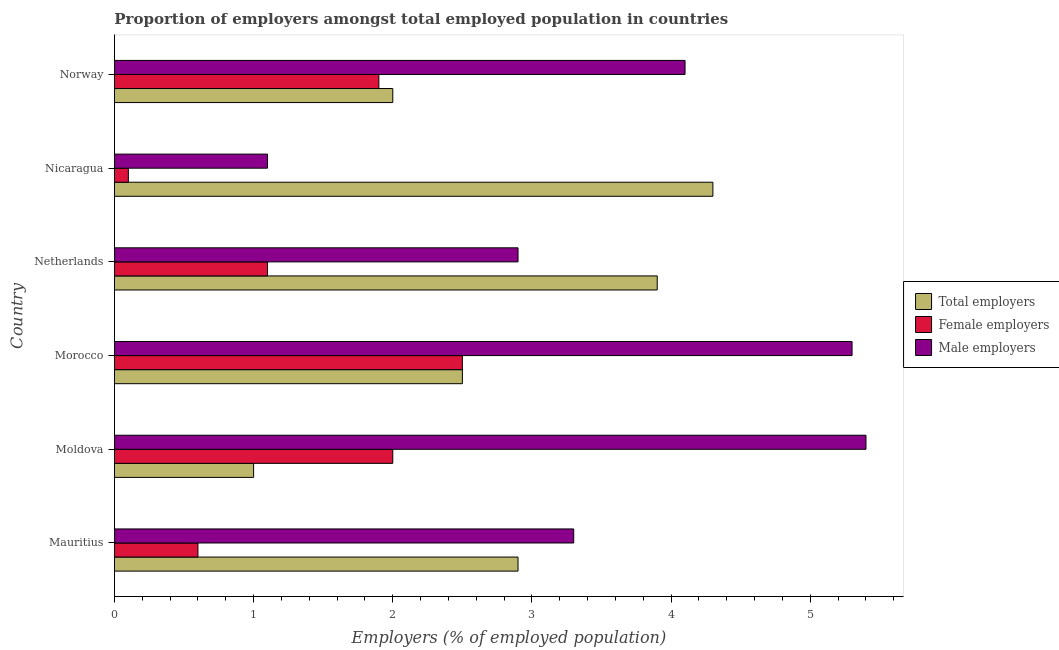How many different coloured bars are there?
Your answer should be compact. 3. Are the number of bars on each tick of the Y-axis equal?
Provide a short and direct response. Yes. How many bars are there on the 4th tick from the bottom?
Make the answer very short. 3. In how many cases, is the number of bars for a given country not equal to the number of legend labels?
Your answer should be very brief. 0. What is the percentage of male employers in Mauritius?
Your answer should be very brief. 3.3. In which country was the percentage of total employers maximum?
Make the answer very short. Nicaragua. In which country was the percentage of male employers minimum?
Offer a terse response. Nicaragua. What is the total percentage of male employers in the graph?
Provide a succinct answer. 22.1. What is the difference between the percentage of female employers in Moldova and that in Netherlands?
Offer a terse response. 0.9. What is the difference between the percentage of total employers in Norway and the percentage of female employers in Mauritius?
Keep it short and to the point. 1.4. What is the average percentage of female employers per country?
Offer a terse response. 1.37. In how many countries, is the percentage of female employers greater than 4 %?
Your answer should be compact. 0. What is the difference between the highest and the lowest percentage of male employers?
Provide a short and direct response. 4.3. What does the 2nd bar from the top in Norway represents?
Make the answer very short. Female employers. What does the 1st bar from the bottom in Mauritius represents?
Offer a terse response. Total employers. Is it the case that in every country, the sum of the percentage of total employers and percentage of female employers is greater than the percentage of male employers?
Provide a succinct answer. No. Are the values on the major ticks of X-axis written in scientific E-notation?
Offer a terse response. No. Does the graph contain any zero values?
Your answer should be compact. No. Does the graph contain grids?
Your response must be concise. No. Where does the legend appear in the graph?
Your response must be concise. Center right. What is the title of the graph?
Your answer should be compact. Proportion of employers amongst total employed population in countries. Does "Taxes on income" appear as one of the legend labels in the graph?
Give a very brief answer. No. What is the label or title of the X-axis?
Give a very brief answer. Employers (% of employed population). What is the label or title of the Y-axis?
Offer a terse response. Country. What is the Employers (% of employed population) of Total employers in Mauritius?
Your answer should be very brief. 2.9. What is the Employers (% of employed population) in Female employers in Mauritius?
Keep it short and to the point. 0.6. What is the Employers (% of employed population) in Male employers in Mauritius?
Your answer should be very brief. 3.3. What is the Employers (% of employed population) of Total employers in Moldova?
Keep it short and to the point. 1. What is the Employers (% of employed population) of Female employers in Moldova?
Give a very brief answer. 2. What is the Employers (% of employed population) of Male employers in Moldova?
Your response must be concise. 5.4. What is the Employers (% of employed population) of Male employers in Morocco?
Give a very brief answer. 5.3. What is the Employers (% of employed population) of Total employers in Netherlands?
Provide a succinct answer. 3.9. What is the Employers (% of employed population) in Female employers in Netherlands?
Keep it short and to the point. 1.1. What is the Employers (% of employed population) of Male employers in Netherlands?
Offer a terse response. 2.9. What is the Employers (% of employed population) in Total employers in Nicaragua?
Give a very brief answer. 4.3. What is the Employers (% of employed population) of Female employers in Nicaragua?
Ensure brevity in your answer.  0.1. What is the Employers (% of employed population) of Male employers in Nicaragua?
Give a very brief answer. 1.1. What is the Employers (% of employed population) of Total employers in Norway?
Your answer should be compact. 2. What is the Employers (% of employed population) of Female employers in Norway?
Your answer should be compact. 1.9. What is the Employers (% of employed population) in Male employers in Norway?
Provide a succinct answer. 4.1. Across all countries, what is the maximum Employers (% of employed population) of Total employers?
Offer a very short reply. 4.3. Across all countries, what is the maximum Employers (% of employed population) in Male employers?
Make the answer very short. 5.4. Across all countries, what is the minimum Employers (% of employed population) of Total employers?
Your response must be concise. 1. Across all countries, what is the minimum Employers (% of employed population) in Female employers?
Make the answer very short. 0.1. Across all countries, what is the minimum Employers (% of employed population) in Male employers?
Provide a short and direct response. 1.1. What is the total Employers (% of employed population) of Male employers in the graph?
Make the answer very short. 22.1. What is the difference between the Employers (% of employed population) in Female employers in Mauritius and that in Moldova?
Give a very brief answer. -1.4. What is the difference between the Employers (% of employed population) in Male employers in Mauritius and that in Morocco?
Ensure brevity in your answer.  -2. What is the difference between the Employers (% of employed population) in Female employers in Mauritius and that in Netherlands?
Make the answer very short. -0.5. What is the difference between the Employers (% of employed population) of Total employers in Mauritius and that in Nicaragua?
Your answer should be very brief. -1.4. What is the difference between the Employers (% of employed population) of Female employers in Mauritius and that in Nicaragua?
Keep it short and to the point. 0.5. What is the difference between the Employers (% of employed population) of Male employers in Mauritius and that in Nicaragua?
Your response must be concise. 2.2. What is the difference between the Employers (% of employed population) in Female employers in Mauritius and that in Norway?
Provide a short and direct response. -1.3. What is the difference between the Employers (% of employed population) in Total employers in Moldova and that in Morocco?
Offer a very short reply. -1.5. What is the difference between the Employers (% of employed population) in Female employers in Moldova and that in Morocco?
Your response must be concise. -0.5. What is the difference between the Employers (% of employed population) of Male employers in Moldova and that in Morocco?
Provide a short and direct response. 0.1. What is the difference between the Employers (% of employed population) in Total employers in Moldova and that in Netherlands?
Make the answer very short. -2.9. What is the difference between the Employers (% of employed population) in Female employers in Moldova and that in Netherlands?
Give a very brief answer. 0.9. What is the difference between the Employers (% of employed population) in Male employers in Moldova and that in Netherlands?
Keep it short and to the point. 2.5. What is the difference between the Employers (% of employed population) in Female employers in Moldova and that in Nicaragua?
Give a very brief answer. 1.9. What is the difference between the Employers (% of employed population) of Male employers in Moldova and that in Nicaragua?
Keep it short and to the point. 4.3. What is the difference between the Employers (% of employed population) in Total employers in Moldova and that in Norway?
Your answer should be compact. -1. What is the difference between the Employers (% of employed population) in Female employers in Moldova and that in Norway?
Provide a short and direct response. 0.1. What is the difference between the Employers (% of employed population) of Total employers in Morocco and that in Norway?
Give a very brief answer. 0.5. What is the difference between the Employers (% of employed population) of Female employers in Morocco and that in Norway?
Give a very brief answer. 0.6. What is the difference between the Employers (% of employed population) in Male employers in Morocco and that in Norway?
Ensure brevity in your answer.  1.2. What is the difference between the Employers (% of employed population) in Total employers in Netherlands and that in Nicaragua?
Keep it short and to the point. -0.4. What is the difference between the Employers (% of employed population) of Male employers in Netherlands and that in Nicaragua?
Your answer should be compact. 1.8. What is the difference between the Employers (% of employed population) of Female employers in Netherlands and that in Norway?
Your answer should be very brief. -0.8. What is the difference between the Employers (% of employed population) in Male employers in Nicaragua and that in Norway?
Offer a terse response. -3. What is the difference between the Employers (% of employed population) in Total employers in Mauritius and the Employers (% of employed population) in Female employers in Morocco?
Provide a succinct answer. 0.4. What is the difference between the Employers (% of employed population) of Total employers in Mauritius and the Employers (% of employed population) of Male employers in Morocco?
Offer a very short reply. -2.4. What is the difference between the Employers (% of employed population) in Total employers in Mauritius and the Employers (% of employed population) in Female employers in Netherlands?
Your answer should be compact. 1.8. What is the difference between the Employers (% of employed population) of Female employers in Mauritius and the Employers (% of employed population) of Male employers in Netherlands?
Ensure brevity in your answer.  -2.3. What is the difference between the Employers (% of employed population) in Female employers in Mauritius and the Employers (% of employed population) in Male employers in Nicaragua?
Offer a very short reply. -0.5. What is the difference between the Employers (% of employed population) in Total employers in Mauritius and the Employers (% of employed population) in Female employers in Norway?
Your answer should be compact. 1. What is the difference between the Employers (% of employed population) in Total employers in Mauritius and the Employers (% of employed population) in Male employers in Norway?
Give a very brief answer. -1.2. What is the difference between the Employers (% of employed population) of Total employers in Moldova and the Employers (% of employed population) of Female employers in Morocco?
Make the answer very short. -1.5. What is the difference between the Employers (% of employed population) of Total employers in Moldova and the Employers (% of employed population) of Male employers in Morocco?
Keep it short and to the point. -4.3. What is the difference between the Employers (% of employed population) in Female employers in Moldova and the Employers (% of employed population) in Male employers in Morocco?
Your response must be concise. -3.3. What is the difference between the Employers (% of employed population) of Total employers in Moldova and the Employers (% of employed population) of Female employers in Netherlands?
Make the answer very short. -0.1. What is the difference between the Employers (% of employed population) in Total employers in Moldova and the Employers (% of employed population) in Male employers in Netherlands?
Offer a very short reply. -1.9. What is the difference between the Employers (% of employed population) in Female employers in Moldova and the Employers (% of employed population) in Male employers in Netherlands?
Give a very brief answer. -0.9. What is the difference between the Employers (% of employed population) of Total employers in Moldova and the Employers (% of employed population) of Male employers in Nicaragua?
Provide a succinct answer. -0.1. What is the difference between the Employers (% of employed population) of Total employers in Moldova and the Employers (% of employed population) of Male employers in Norway?
Keep it short and to the point. -3.1. What is the difference between the Employers (% of employed population) of Female employers in Moldova and the Employers (% of employed population) of Male employers in Norway?
Offer a very short reply. -2.1. What is the difference between the Employers (% of employed population) of Female employers in Morocco and the Employers (% of employed population) of Male employers in Netherlands?
Ensure brevity in your answer.  -0.4. What is the difference between the Employers (% of employed population) of Total employers in Morocco and the Employers (% of employed population) of Male employers in Nicaragua?
Give a very brief answer. 1.4. What is the difference between the Employers (% of employed population) in Female employers in Morocco and the Employers (% of employed population) in Male employers in Nicaragua?
Your answer should be compact. 1.4. What is the difference between the Employers (% of employed population) in Total employers in Morocco and the Employers (% of employed population) in Female employers in Norway?
Provide a succinct answer. 0.6. What is the difference between the Employers (% of employed population) of Total employers in Morocco and the Employers (% of employed population) of Male employers in Norway?
Offer a terse response. -1.6. What is the difference between the Employers (% of employed population) of Total employers in Netherlands and the Employers (% of employed population) of Female employers in Norway?
Provide a short and direct response. 2. What is the difference between the Employers (% of employed population) in Total employers in Netherlands and the Employers (% of employed population) in Male employers in Norway?
Make the answer very short. -0.2. What is the difference between the Employers (% of employed population) of Female employers in Netherlands and the Employers (% of employed population) of Male employers in Norway?
Offer a very short reply. -3. What is the difference between the Employers (% of employed population) in Total employers in Nicaragua and the Employers (% of employed population) in Female employers in Norway?
Your response must be concise. 2.4. What is the difference between the Employers (% of employed population) in Female employers in Nicaragua and the Employers (% of employed population) in Male employers in Norway?
Your response must be concise. -4. What is the average Employers (% of employed population) in Total employers per country?
Give a very brief answer. 2.77. What is the average Employers (% of employed population) of Female employers per country?
Offer a very short reply. 1.37. What is the average Employers (% of employed population) of Male employers per country?
Your answer should be very brief. 3.68. What is the difference between the Employers (% of employed population) of Total employers and Employers (% of employed population) of Female employers in Mauritius?
Make the answer very short. 2.3. What is the difference between the Employers (% of employed population) of Total employers and Employers (% of employed population) of Male employers in Mauritius?
Make the answer very short. -0.4. What is the difference between the Employers (% of employed population) of Total employers and Employers (% of employed population) of Female employers in Moldova?
Give a very brief answer. -1. What is the difference between the Employers (% of employed population) in Total employers and Employers (% of employed population) in Male employers in Moldova?
Your answer should be very brief. -4.4. What is the difference between the Employers (% of employed population) in Total employers and Employers (% of employed population) in Female employers in Morocco?
Make the answer very short. 0. What is the difference between the Employers (% of employed population) in Total employers and Employers (% of employed population) in Male employers in Morocco?
Your answer should be very brief. -2.8. What is the difference between the Employers (% of employed population) of Total employers and Employers (% of employed population) of Female employers in Netherlands?
Offer a very short reply. 2.8. What is the difference between the Employers (% of employed population) in Female employers and Employers (% of employed population) in Male employers in Netherlands?
Your answer should be compact. -1.8. What is the difference between the Employers (% of employed population) in Total employers and Employers (% of employed population) in Male employers in Nicaragua?
Your answer should be very brief. 3.2. What is the difference between the Employers (% of employed population) in Female employers and Employers (% of employed population) in Male employers in Nicaragua?
Provide a short and direct response. -1. What is the difference between the Employers (% of employed population) of Female employers and Employers (% of employed population) of Male employers in Norway?
Offer a very short reply. -2.2. What is the ratio of the Employers (% of employed population) of Total employers in Mauritius to that in Moldova?
Ensure brevity in your answer.  2.9. What is the ratio of the Employers (% of employed population) in Male employers in Mauritius to that in Moldova?
Your response must be concise. 0.61. What is the ratio of the Employers (% of employed population) of Total employers in Mauritius to that in Morocco?
Ensure brevity in your answer.  1.16. What is the ratio of the Employers (% of employed population) of Female employers in Mauritius to that in Morocco?
Provide a succinct answer. 0.24. What is the ratio of the Employers (% of employed population) in Male employers in Mauritius to that in Morocco?
Your answer should be very brief. 0.62. What is the ratio of the Employers (% of employed population) of Total employers in Mauritius to that in Netherlands?
Offer a very short reply. 0.74. What is the ratio of the Employers (% of employed population) in Female employers in Mauritius to that in Netherlands?
Your answer should be very brief. 0.55. What is the ratio of the Employers (% of employed population) of Male employers in Mauritius to that in Netherlands?
Ensure brevity in your answer.  1.14. What is the ratio of the Employers (% of employed population) in Total employers in Mauritius to that in Nicaragua?
Your response must be concise. 0.67. What is the ratio of the Employers (% of employed population) of Female employers in Mauritius to that in Nicaragua?
Give a very brief answer. 6. What is the ratio of the Employers (% of employed population) in Total employers in Mauritius to that in Norway?
Provide a succinct answer. 1.45. What is the ratio of the Employers (% of employed population) of Female employers in Mauritius to that in Norway?
Give a very brief answer. 0.32. What is the ratio of the Employers (% of employed population) of Male employers in Mauritius to that in Norway?
Your answer should be compact. 0.8. What is the ratio of the Employers (% of employed population) in Male employers in Moldova to that in Morocco?
Your answer should be very brief. 1.02. What is the ratio of the Employers (% of employed population) in Total employers in Moldova to that in Netherlands?
Ensure brevity in your answer.  0.26. What is the ratio of the Employers (% of employed population) in Female employers in Moldova to that in Netherlands?
Offer a very short reply. 1.82. What is the ratio of the Employers (% of employed population) of Male employers in Moldova to that in Netherlands?
Your response must be concise. 1.86. What is the ratio of the Employers (% of employed population) of Total employers in Moldova to that in Nicaragua?
Make the answer very short. 0.23. What is the ratio of the Employers (% of employed population) of Female employers in Moldova to that in Nicaragua?
Your answer should be very brief. 20. What is the ratio of the Employers (% of employed population) in Male employers in Moldova to that in Nicaragua?
Offer a terse response. 4.91. What is the ratio of the Employers (% of employed population) of Female employers in Moldova to that in Norway?
Your answer should be compact. 1.05. What is the ratio of the Employers (% of employed population) of Male employers in Moldova to that in Norway?
Provide a succinct answer. 1.32. What is the ratio of the Employers (% of employed population) of Total employers in Morocco to that in Netherlands?
Provide a short and direct response. 0.64. What is the ratio of the Employers (% of employed population) in Female employers in Morocco to that in Netherlands?
Give a very brief answer. 2.27. What is the ratio of the Employers (% of employed population) in Male employers in Morocco to that in Netherlands?
Provide a short and direct response. 1.83. What is the ratio of the Employers (% of employed population) in Total employers in Morocco to that in Nicaragua?
Provide a short and direct response. 0.58. What is the ratio of the Employers (% of employed population) of Female employers in Morocco to that in Nicaragua?
Offer a terse response. 25. What is the ratio of the Employers (% of employed population) in Male employers in Morocco to that in Nicaragua?
Make the answer very short. 4.82. What is the ratio of the Employers (% of employed population) of Female employers in Morocco to that in Norway?
Make the answer very short. 1.32. What is the ratio of the Employers (% of employed population) in Male employers in Morocco to that in Norway?
Offer a very short reply. 1.29. What is the ratio of the Employers (% of employed population) of Total employers in Netherlands to that in Nicaragua?
Your answer should be compact. 0.91. What is the ratio of the Employers (% of employed population) of Male employers in Netherlands to that in Nicaragua?
Make the answer very short. 2.64. What is the ratio of the Employers (% of employed population) in Total employers in Netherlands to that in Norway?
Give a very brief answer. 1.95. What is the ratio of the Employers (% of employed population) of Female employers in Netherlands to that in Norway?
Keep it short and to the point. 0.58. What is the ratio of the Employers (% of employed population) in Male employers in Netherlands to that in Norway?
Your answer should be very brief. 0.71. What is the ratio of the Employers (% of employed population) of Total employers in Nicaragua to that in Norway?
Keep it short and to the point. 2.15. What is the ratio of the Employers (% of employed population) of Female employers in Nicaragua to that in Norway?
Offer a very short reply. 0.05. What is the ratio of the Employers (% of employed population) of Male employers in Nicaragua to that in Norway?
Make the answer very short. 0.27. What is the difference between the highest and the second highest Employers (% of employed population) in Total employers?
Ensure brevity in your answer.  0.4. What is the difference between the highest and the lowest Employers (% of employed population) of Total employers?
Give a very brief answer. 3.3. What is the difference between the highest and the lowest Employers (% of employed population) in Female employers?
Ensure brevity in your answer.  2.4. 